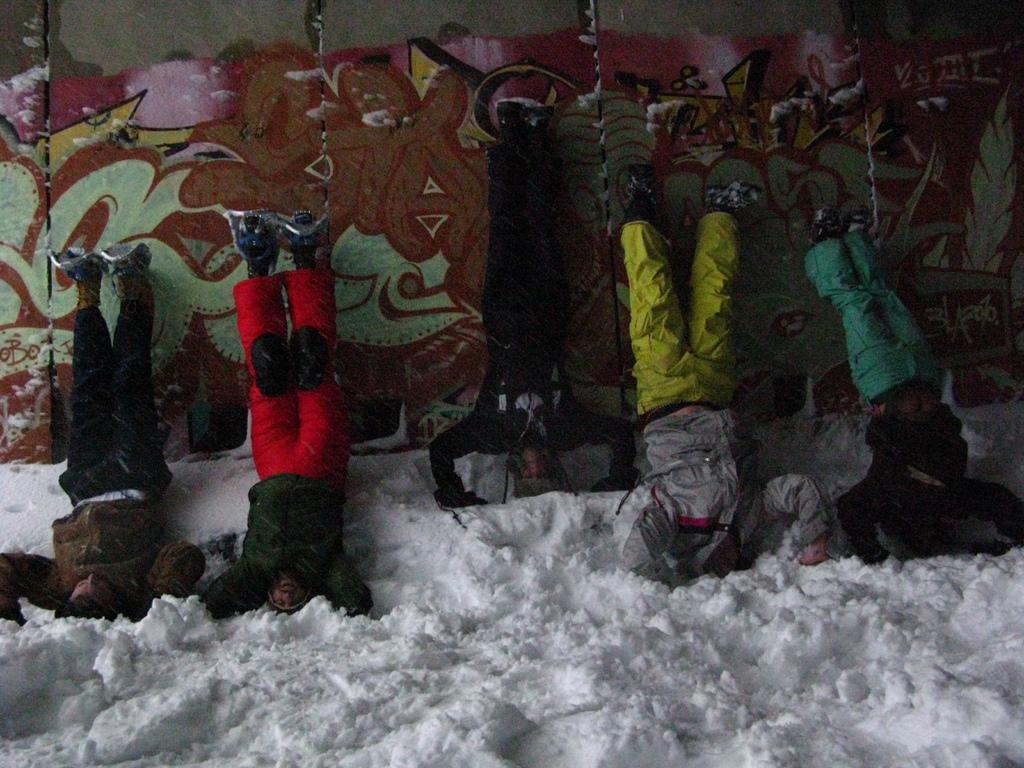Could you give a brief overview of what you see in this image? At the bottom of the image there is snow. In the middle of the image few people are doing something. Behind them there is wall. 